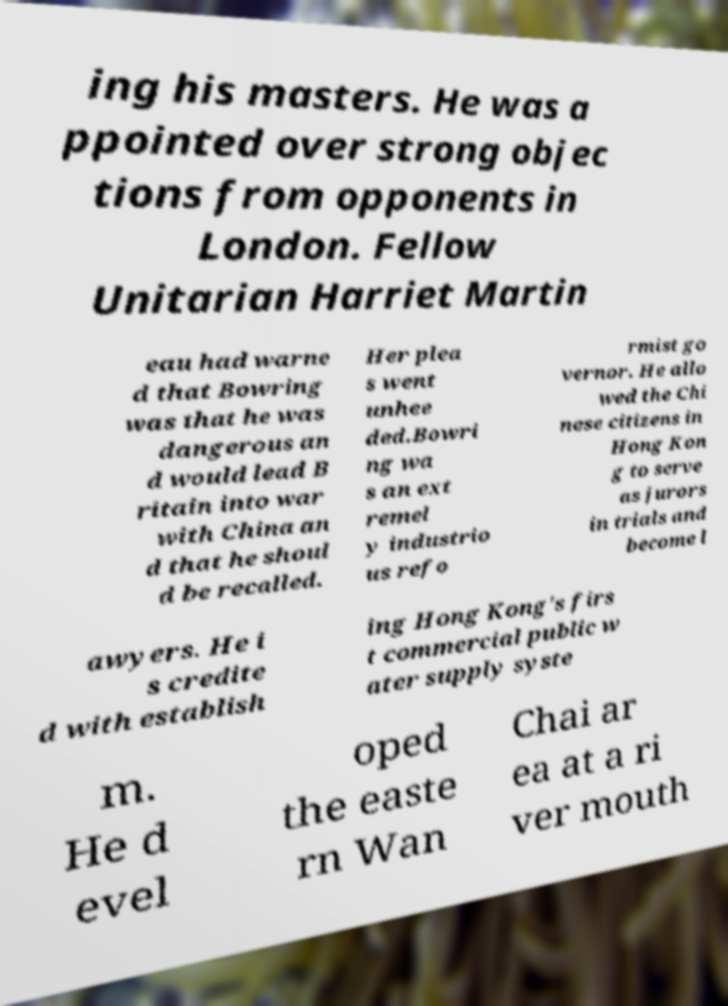Can you read and provide the text displayed in the image?This photo seems to have some interesting text. Can you extract and type it out for me? ing his masters. He was a ppointed over strong objec tions from opponents in London. Fellow Unitarian Harriet Martin eau had warne d that Bowring was that he was dangerous an d would lead B ritain into war with China an d that he shoul d be recalled. Her plea s went unhee ded.Bowri ng wa s an ext remel y industrio us refo rmist go vernor. He allo wed the Chi nese citizens in Hong Kon g to serve as jurors in trials and become l awyers. He i s credite d with establish ing Hong Kong's firs t commercial public w ater supply syste m. He d evel oped the easte rn Wan Chai ar ea at a ri ver mouth 